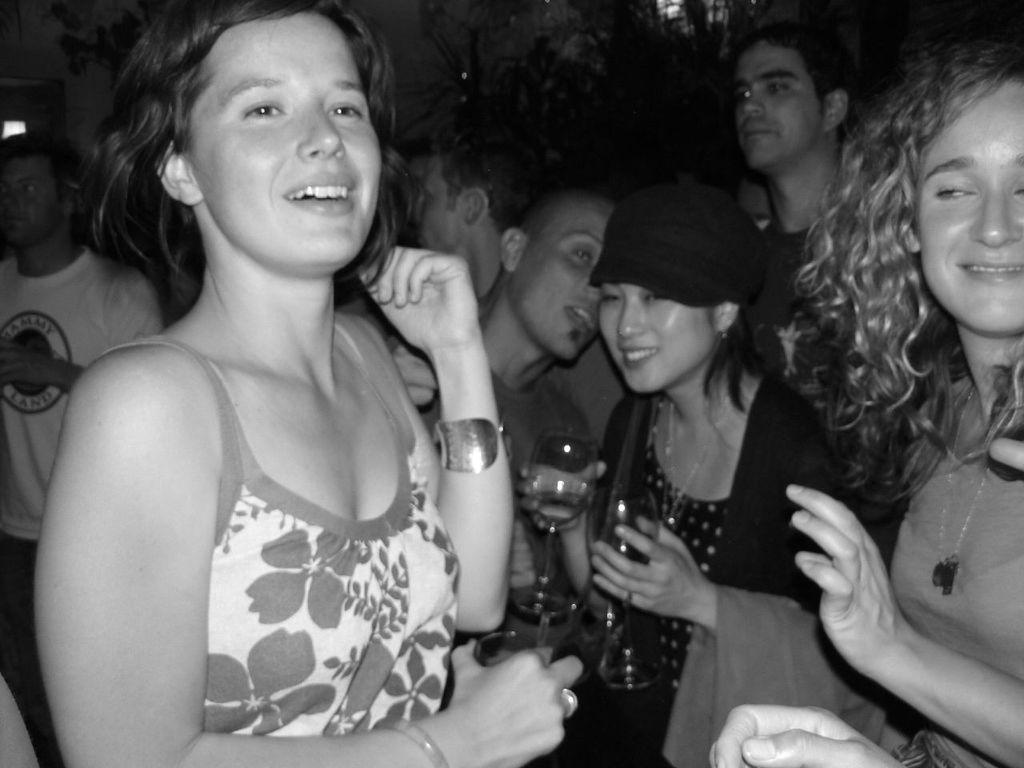What is the color scheme of the image? The image is black and white. What type of scene is depicted in the image? It appears to appears to be a party scene. How many people are present in the image? There are many people gathered in the image. What are some people holding in their hands? Some people are holding glasses in their hands. How would you describe the mood of the people in the image? The people in the image are enjoying themselves. Can you see any goats or streams in the image? No, there are no goats or streams present in the image. Are there any clams visible in the image? No, there are no clams visible in the image. 